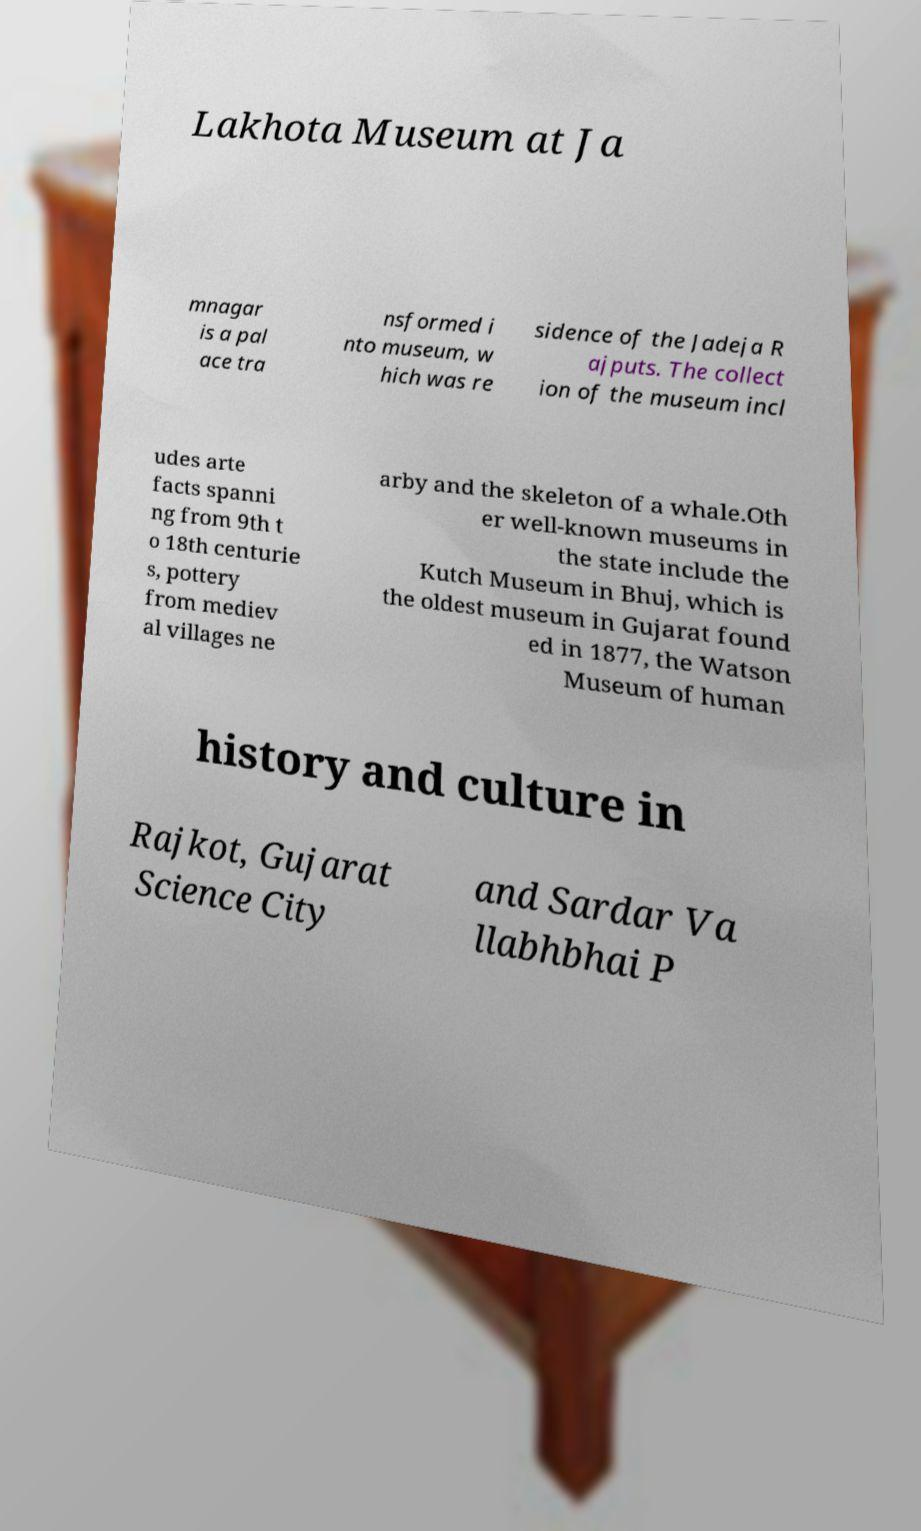There's text embedded in this image that I need extracted. Can you transcribe it verbatim? Lakhota Museum at Ja mnagar is a pal ace tra nsformed i nto museum, w hich was re sidence of the Jadeja R ajputs. The collect ion of the museum incl udes arte facts spanni ng from 9th t o 18th centurie s, pottery from mediev al villages ne arby and the skeleton of a whale.Oth er well-known museums in the state include the Kutch Museum in Bhuj, which is the oldest museum in Gujarat found ed in 1877, the Watson Museum of human history and culture in Rajkot, Gujarat Science City and Sardar Va llabhbhai P 